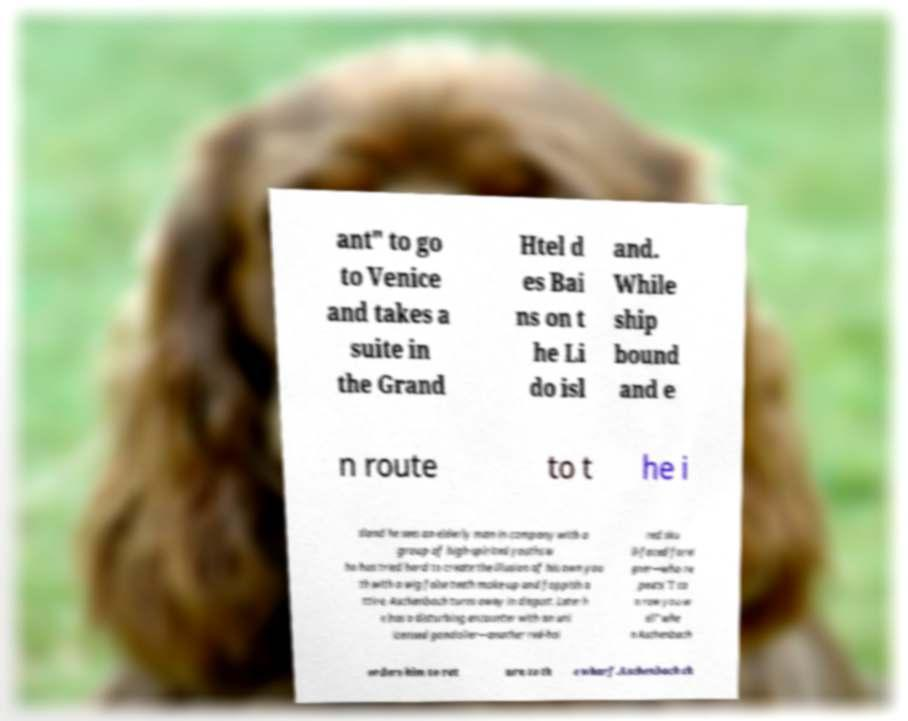Please read and relay the text visible in this image. What does it say? ant" to go to Venice and takes a suite in the Grand Htel d es Bai ns on t he Li do isl and. While ship bound and e n route to t he i sland he sees an elderly man in company with a group of high-spirited youths w ho has tried hard to create the illusion of his own you th with a wig false teeth make-up and foppish a ttire. Aschenbach turns away in disgust. Later h e has a disturbing encounter with an unl icensed gondolier—another red-hai red sku ll-faced forei gner—who re peats "I ca n row you w ell" whe n Aschenbach orders him to ret urn to th e wharf.Aschenbach ch 